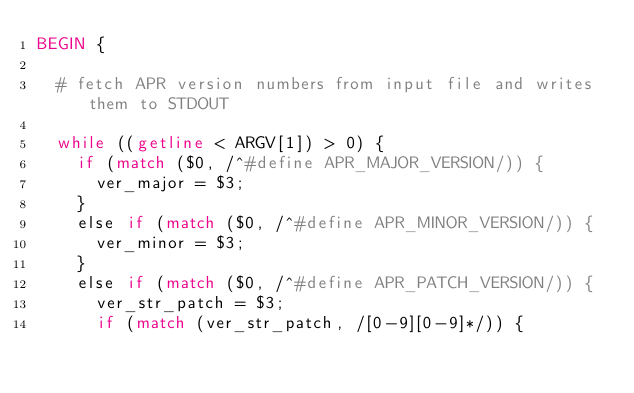Convert code to text. <code><loc_0><loc_0><loc_500><loc_500><_Awk_>BEGIN {

  # fetch APR version numbers from input file and writes them to STDOUT

  while ((getline < ARGV[1]) > 0) {
    if (match ($0, /^#define APR_MAJOR_VERSION/)) {
      ver_major = $3;
    }
    else if (match ($0, /^#define APR_MINOR_VERSION/)) {
      ver_minor = $3;
    }
    else if (match ($0, /^#define APR_PATCH_VERSION/)) {
      ver_str_patch = $3;
      if (match (ver_str_patch, /[0-9][0-9]*/)) {</code> 